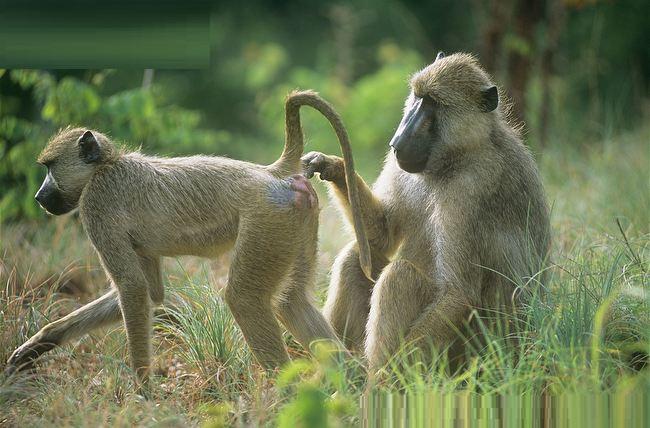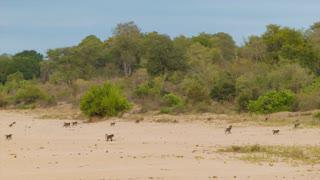The first image is the image on the left, the second image is the image on the right. For the images displayed, is the sentence "Several primates are situated on a dirt roadway." factually correct? Answer yes or no. No. 